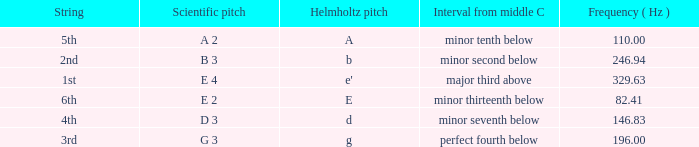What is the lowest Frequency where the Hemholtz pitch is d? 146.83. 